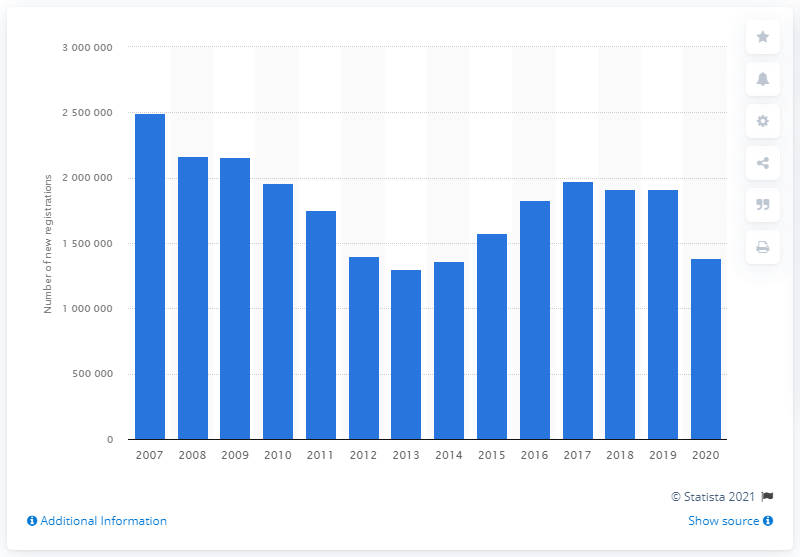Draw attention to some important aspects in this diagram. The Italian passenger car market experienced a significant downturn in 2020. 